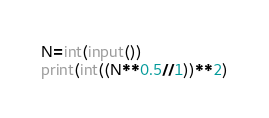<code> <loc_0><loc_0><loc_500><loc_500><_Python_>N=int(input())
print(int((N**0.5//1))**2)</code> 